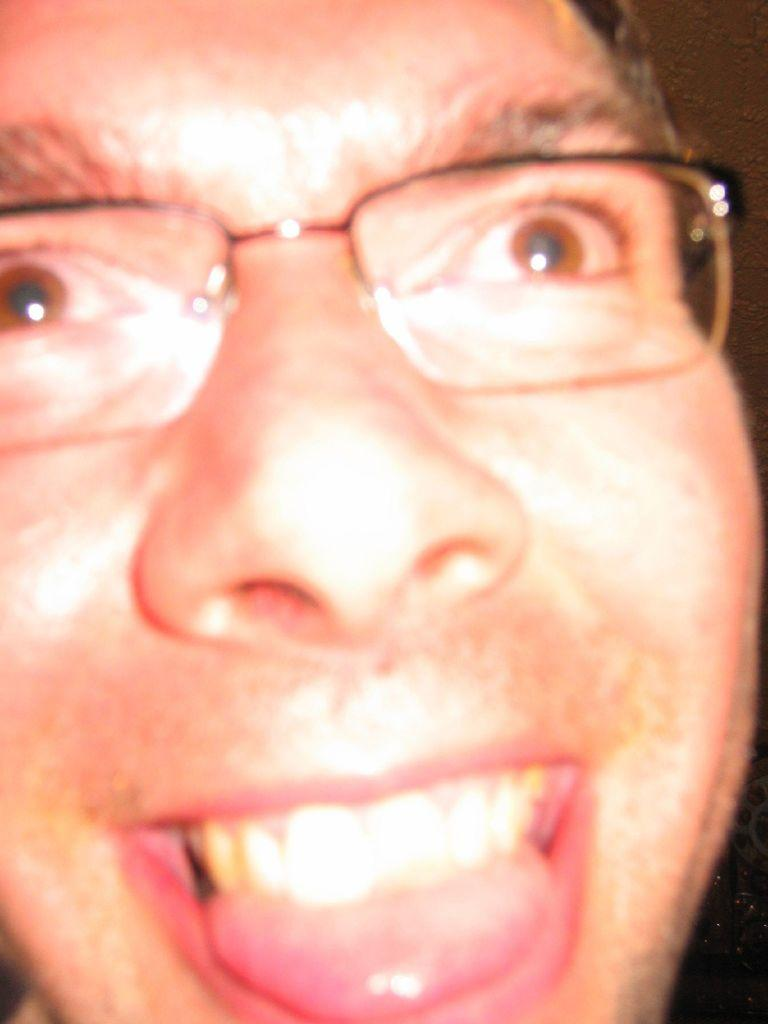Who or what is the main subject of the image? There is a person in the image. What is the person doing in the image? The person is showing their tongue. Are there any accessories or items of clothing visible on the person? Yes, the person is wearing glasses. What type of crown is the person wearing in the image? There is no crown present in the image; the person is wearing glasses. How many friends can be seen in the image? There are no friends visible in the image; it only features one person. 